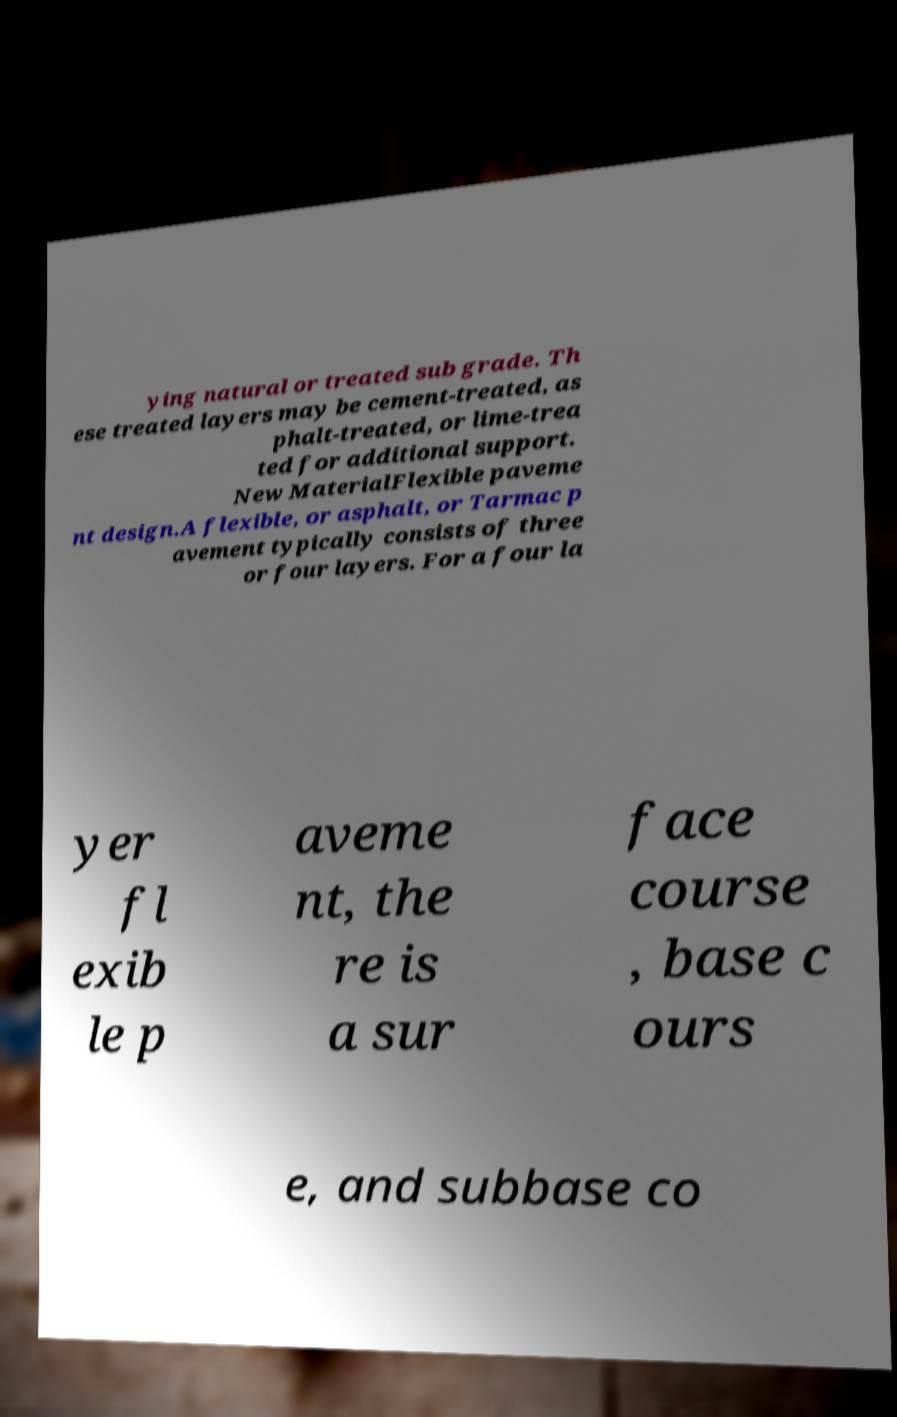I need the written content from this picture converted into text. Can you do that? ying natural or treated sub grade. Th ese treated layers may be cement-treated, as phalt-treated, or lime-trea ted for additional support. New MaterialFlexible paveme nt design.A flexible, or asphalt, or Tarmac p avement typically consists of three or four layers. For a four la yer fl exib le p aveme nt, the re is a sur face course , base c ours e, and subbase co 